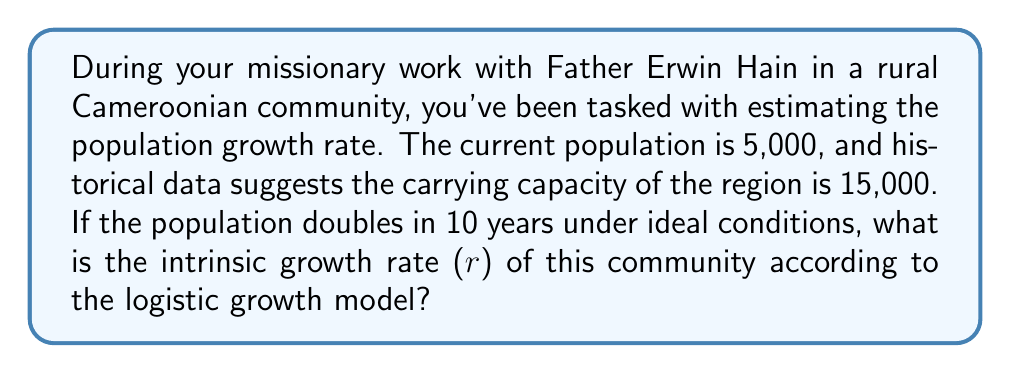Can you solve this math problem? To solve this problem, we'll use the logistic growth model and the given information. The logistic growth model is given by:

$$\frac{dN}{dt} = rN(1 - \frac{N}{K})$$

Where:
$N$ is the population size
$t$ is time
$r$ is the intrinsic growth rate
$K$ is the carrying capacity

We're given:
- Initial population $N_0 = 5,000$
- Carrying capacity $K = 15,000$
- Population doubles in 10 years under ideal conditions

Step 1: Under ideal conditions (when $N$ is small compared to $K$), the logistic model approximates exponential growth:

$$\frac{dN}{dt} \approx rN$$

Step 2: Solve the exponential growth equation:
$$N(t) = N_0e^{rt}$$

Step 3: Use the doubling condition:
$$10,000 = 5,000e^{10r}$$

Step 4: Solve for $r$:
$$2 = e^{10r}$$
$$\ln(2) = 10r$$
$$r = \frac{\ln(2)}{10} \approx 0.0693$$

Therefore, the intrinsic growth rate $r$ is approximately 0.0693 or 6.93% per year.
Answer: $r \approx 0.0693$ or 6.93% per year 